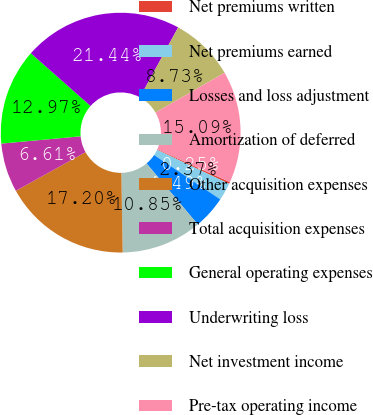<chart> <loc_0><loc_0><loc_500><loc_500><pie_chart><fcel>Net premiums written<fcel>Net premiums earned<fcel>Losses and loss adjustment<fcel>Amortization of deferred<fcel>Other acquisition expenses<fcel>Total acquisition expenses<fcel>General operating expenses<fcel>Underwriting loss<fcel>Net investment income<fcel>Pre-tax operating income<nl><fcel>0.25%<fcel>2.37%<fcel>4.49%<fcel>10.85%<fcel>17.2%<fcel>6.61%<fcel>12.97%<fcel>21.44%<fcel>8.73%<fcel>15.09%<nl></chart> 